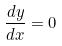Convert formula to latex. <formula><loc_0><loc_0><loc_500><loc_500>\frac { d y } { d x } = 0</formula> 